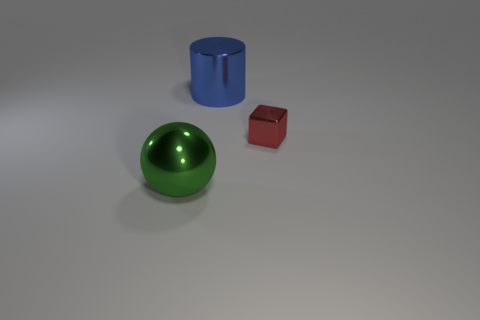Add 3 shiny cubes. How many objects exist? 6 Subtract all cylinders. How many objects are left? 2 Add 2 tiny objects. How many tiny objects are left? 3 Add 3 big balls. How many big balls exist? 4 Subtract 0 purple cylinders. How many objects are left? 3 Subtract all blue metallic blocks. Subtract all small shiny objects. How many objects are left? 2 